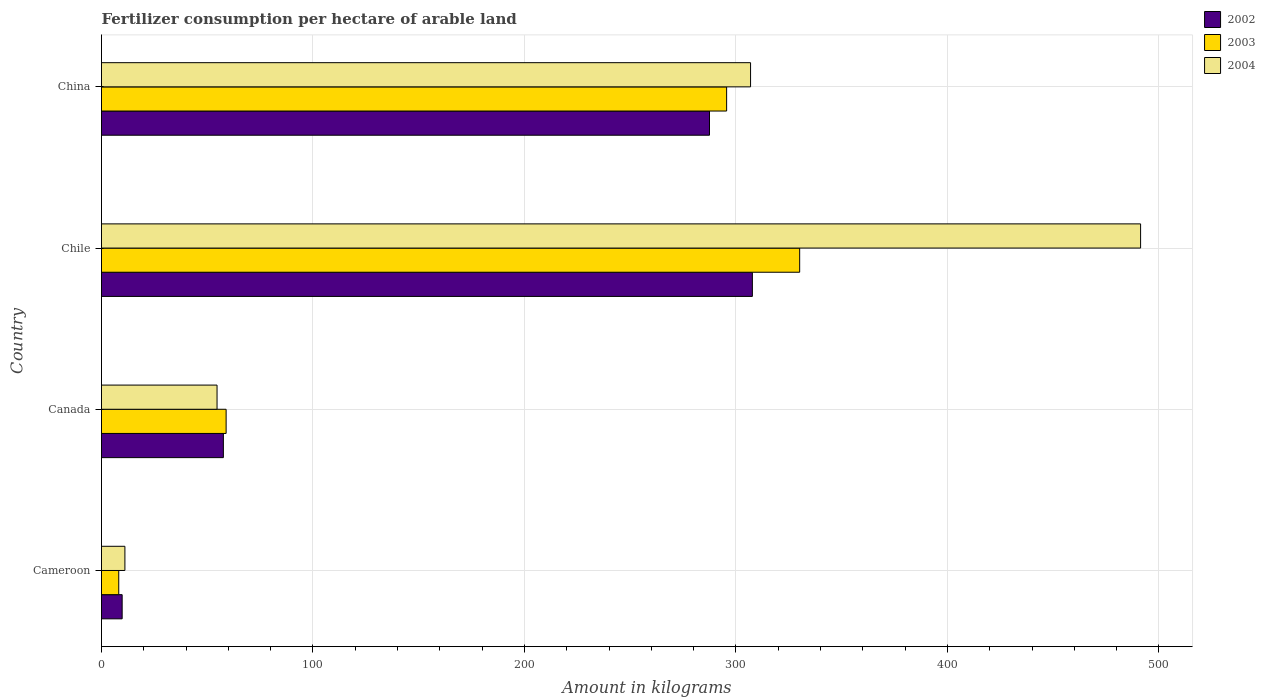How many different coloured bars are there?
Your answer should be compact. 3. What is the label of the 1st group of bars from the top?
Your answer should be very brief. China. What is the amount of fertilizer consumption in 2004 in China?
Offer a terse response. 306.92. Across all countries, what is the maximum amount of fertilizer consumption in 2002?
Ensure brevity in your answer.  307.77. Across all countries, what is the minimum amount of fertilizer consumption in 2003?
Offer a very short reply. 8.16. In which country was the amount of fertilizer consumption in 2004 minimum?
Your answer should be compact. Cameroon. What is the total amount of fertilizer consumption in 2004 in the graph?
Give a very brief answer. 863.97. What is the difference between the amount of fertilizer consumption in 2003 in Canada and that in China?
Offer a very short reply. -236.67. What is the difference between the amount of fertilizer consumption in 2002 in China and the amount of fertilizer consumption in 2003 in Chile?
Make the answer very short. -42.64. What is the average amount of fertilizer consumption in 2002 per country?
Provide a short and direct response. 165.67. What is the difference between the amount of fertilizer consumption in 2004 and amount of fertilizer consumption in 2002 in Chile?
Offer a very short reply. 183.58. In how many countries, is the amount of fertilizer consumption in 2004 greater than 220 kg?
Your answer should be compact. 2. What is the ratio of the amount of fertilizer consumption in 2003 in Cameroon to that in Canada?
Make the answer very short. 0.14. What is the difference between the highest and the second highest amount of fertilizer consumption in 2003?
Give a very brief answer. 34.55. What is the difference between the highest and the lowest amount of fertilizer consumption in 2002?
Offer a terse response. 298. In how many countries, is the amount of fertilizer consumption in 2003 greater than the average amount of fertilizer consumption in 2003 taken over all countries?
Make the answer very short. 2. Is the sum of the amount of fertilizer consumption in 2003 in Cameroon and China greater than the maximum amount of fertilizer consumption in 2004 across all countries?
Give a very brief answer. No. What does the 3rd bar from the top in Chile represents?
Offer a terse response. 2002. What does the 3rd bar from the bottom in Canada represents?
Offer a very short reply. 2004. How many bars are there?
Provide a succinct answer. 12. Are all the bars in the graph horizontal?
Offer a terse response. Yes. How many countries are there in the graph?
Ensure brevity in your answer.  4. Are the values on the major ticks of X-axis written in scientific E-notation?
Make the answer very short. No. Does the graph contain any zero values?
Ensure brevity in your answer.  No. Does the graph contain grids?
Offer a very short reply. Yes. How many legend labels are there?
Keep it short and to the point. 3. How are the legend labels stacked?
Offer a very short reply. Vertical. What is the title of the graph?
Your response must be concise. Fertilizer consumption per hectare of arable land. Does "1961" appear as one of the legend labels in the graph?
Keep it short and to the point. No. What is the label or title of the X-axis?
Keep it short and to the point. Amount in kilograms. What is the Amount in kilograms in 2002 in Cameroon?
Keep it short and to the point. 9.77. What is the Amount in kilograms in 2003 in Cameroon?
Give a very brief answer. 8.16. What is the Amount in kilograms in 2004 in Cameroon?
Ensure brevity in your answer.  11.06. What is the Amount in kilograms of 2002 in Canada?
Your answer should be compact. 57.63. What is the Amount in kilograms of 2003 in Canada?
Make the answer very short. 58.93. What is the Amount in kilograms of 2004 in Canada?
Ensure brevity in your answer.  54.63. What is the Amount in kilograms of 2002 in Chile?
Ensure brevity in your answer.  307.77. What is the Amount in kilograms in 2003 in Chile?
Your answer should be very brief. 330.14. What is the Amount in kilograms of 2004 in Chile?
Make the answer very short. 491.35. What is the Amount in kilograms of 2002 in China?
Your answer should be compact. 287.5. What is the Amount in kilograms in 2003 in China?
Keep it short and to the point. 295.6. What is the Amount in kilograms of 2004 in China?
Make the answer very short. 306.92. Across all countries, what is the maximum Amount in kilograms in 2002?
Make the answer very short. 307.77. Across all countries, what is the maximum Amount in kilograms of 2003?
Provide a succinct answer. 330.14. Across all countries, what is the maximum Amount in kilograms of 2004?
Offer a terse response. 491.35. Across all countries, what is the minimum Amount in kilograms of 2002?
Your answer should be very brief. 9.77. Across all countries, what is the minimum Amount in kilograms in 2003?
Your answer should be compact. 8.16. Across all countries, what is the minimum Amount in kilograms in 2004?
Offer a terse response. 11.06. What is the total Amount in kilograms in 2002 in the graph?
Offer a terse response. 662.67. What is the total Amount in kilograms in 2003 in the graph?
Provide a short and direct response. 692.82. What is the total Amount in kilograms in 2004 in the graph?
Your answer should be very brief. 863.97. What is the difference between the Amount in kilograms of 2002 in Cameroon and that in Canada?
Your answer should be very brief. -47.86. What is the difference between the Amount in kilograms in 2003 in Cameroon and that in Canada?
Offer a terse response. -50.77. What is the difference between the Amount in kilograms in 2004 in Cameroon and that in Canada?
Provide a short and direct response. -43.57. What is the difference between the Amount in kilograms of 2002 in Cameroon and that in Chile?
Keep it short and to the point. -298. What is the difference between the Amount in kilograms in 2003 in Cameroon and that in Chile?
Your response must be concise. -321.99. What is the difference between the Amount in kilograms of 2004 in Cameroon and that in Chile?
Your response must be concise. -480.29. What is the difference between the Amount in kilograms of 2002 in Cameroon and that in China?
Offer a terse response. -277.73. What is the difference between the Amount in kilograms of 2003 in Cameroon and that in China?
Keep it short and to the point. -287.44. What is the difference between the Amount in kilograms in 2004 in Cameroon and that in China?
Provide a succinct answer. -295.85. What is the difference between the Amount in kilograms in 2002 in Canada and that in Chile?
Provide a succinct answer. -250.14. What is the difference between the Amount in kilograms in 2003 in Canada and that in Chile?
Your response must be concise. -271.22. What is the difference between the Amount in kilograms of 2004 in Canada and that in Chile?
Make the answer very short. -436.72. What is the difference between the Amount in kilograms of 2002 in Canada and that in China?
Ensure brevity in your answer.  -229.87. What is the difference between the Amount in kilograms in 2003 in Canada and that in China?
Give a very brief answer. -236.67. What is the difference between the Amount in kilograms in 2004 in Canada and that in China?
Your answer should be compact. -252.28. What is the difference between the Amount in kilograms of 2002 in Chile and that in China?
Ensure brevity in your answer.  20.27. What is the difference between the Amount in kilograms in 2003 in Chile and that in China?
Offer a very short reply. 34.55. What is the difference between the Amount in kilograms of 2004 in Chile and that in China?
Your answer should be very brief. 184.44. What is the difference between the Amount in kilograms of 2002 in Cameroon and the Amount in kilograms of 2003 in Canada?
Make the answer very short. -49.16. What is the difference between the Amount in kilograms in 2002 in Cameroon and the Amount in kilograms in 2004 in Canada?
Your answer should be compact. -44.86. What is the difference between the Amount in kilograms in 2003 in Cameroon and the Amount in kilograms in 2004 in Canada?
Your response must be concise. -46.48. What is the difference between the Amount in kilograms of 2002 in Cameroon and the Amount in kilograms of 2003 in Chile?
Your answer should be very brief. -320.37. What is the difference between the Amount in kilograms of 2002 in Cameroon and the Amount in kilograms of 2004 in Chile?
Keep it short and to the point. -481.58. What is the difference between the Amount in kilograms in 2003 in Cameroon and the Amount in kilograms in 2004 in Chile?
Your response must be concise. -483.2. What is the difference between the Amount in kilograms of 2002 in Cameroon and the Amount in kilograms of 2003 in China?
Offer a very short reply. -285.83. What is the difference between the Amount in kilograms in 2002 in Cameroon and the Amount in kilograms in 2004 in China?
Ensure brevity in your answer.  -297.15. What is the difference between the Amount in kilograms of 2003 in Cameroon and the Amount in kilograms of 2004 in China?
Offer a very short reply. -298.76. What is the difference between the Amount in kilograms of 2002 in Canada and the Amount in kilograms of 2003 in Chile?
Offer a very short reply. -272.51. What is the difference between the Amount in kilograms of 2002 in Canada and the Amount in kilograms of 2004 in Chile?
Your answer should be very brief. -433.72. What is the difference between the Amount in kilograms of 2003 in Canada and the Amount in kilograms of 2004 in Chile?
Keep it short and to the point. -432.43. What is the difference between the Amount in kilograms in 2002 in Canada and the Amount in kilograms in 2003 in China?
Ensure brevity in your answer.  -237.97. What is the difference between the Amount in kilograms in 2002 in Canada and the Amount in kilograms in 2004 in China?
Offer a terse response. -249.29. What is the difference between the Amount in kilograms of 2003 in Canada and the Amount in kilograms of 2004 in China?
Ensure brevity in your answer.  -247.99. What is the difference between the Amount in kilograms in 2002 in Chile and the Amount in kilograms in 2003 in China?
Your answer should be very brief. 12.18. What is the difference between the Amount in kilograms in 2002 in Chile and the Amount in kilograms in 2004 in China?
Ensure brevity in your answer.  0.86. What is the difference between the Amount in kilograms of 2003 in Chile and the Amount in kilograms of 2004 in China?
Your response must be concise. 23.23. What is the average Amount in kilograms of 2002 per country?
Offer a terse response. 165.67. What is the average Amount in kilograms of 2003 per country?
Your response must be concise. 173.21. What is the average Amount in kilograms of 2004 per country?
Your answer should be very brief. 215.99. What is the difference between the Amount in kilograms of 2002 and Amount in kilograms of 2003 in Cameroon?
Your response must be concise. 1.61. What is the difference between the Amount in kilograms in 2002 and Amount in kilograms in 2004 in Cameroon?
Your response must be concise. -1.29. What is the difference between the Amount in kilograms in 2003 and Amount in kilograms in 2004 in Cameroon?
Offer a very short reply. -2.91. What is the difference between the Amount in kilograms of 2002 and Amount in kilograms of 2003 in Canada?
Keep it short and to the point. -1.3. What is the difference between the Amount in kilograms of 2002 and Amount in kilograms of 2004 in Canada?
Offer a very short reply. 3. What is the difference between the Amount in kilograms of 2003 and Amount in kilograms of 2004 in Canada?
Your response must be concise. 4.29. What is the difference between the Amount in kilograms of 2002 and Amount in kilograms of 2003 in Chile?
Your response must be concise. -22.37. What is the difference between the Amount in kilograms of 2002 and Amount in kilograms of 2004 in Chile?
Offer a terse response. -183.58. What is the difference between the Amount in kilograms in 2003 and Amount in kilograms in 2004 in Chile?
Offer a very short reply. -161.21. What is the difference between the Amount in kilograms in 2002 and Amount in kilograms in 2003 in China?
Keep it short and to the point. -8.09. What is the difference between the Amount in kilograms in 2002 and Amount in kilograms in 2004 in China?
Your answer should be compact. -19.42. What is the difference between the Amount in kilograms in 2003 and Amount in kilograms in 2004 in China?
Your response must be concise. -11.32. What is the ratio of the Amount in kilograms of 2002 in Cameroon to that in Canada?
Keep it short and to the point. 0.17. What is the ratio of the Amount in kilograms in 2003 in Cameroon to that in Canada?
Offer a very short reply. 0.14. What is the ratio of the Amount in kilograms in 2004 in Cameroon to that in Canada?
Your answer should be very brief. 0.2. What is the ratio of the Amount in kilograms in 2002 in Cameroon to that in Chile?
Offer a terse response. 0.03. What is the ratio of the Amount in kilograms in 2003 in Cameroon to that in Chile?
Offer a very short reply. 0.02. What is the ratio of the Amount in kilograms of 2004 in Cameroon to that in Chile?
Your response must be concise. 0.02. What is the ratio of the Amount in kilograms in 2002 in Cameroon to that in China?
Ensure brevity in your answer.  0.03. What is the ratio of the Amount in kilograms of 2003 in Cameroon to that in China?
Provide a succinct answer. 0.03. What is the ratio of the Amount in kilograms in 2004 in Cameroon to that in China?
Give a very brief answer. 0.04. What is the ratio of the Amount in kilograms in 2002 in Canada to that in Chile?
Your answer should be compact. 0.19. What is the ratio of the Amount in kilograms in 2003 in Canada to that in Chile?
Keep it short and to the point. 0.18. What is the ratio of the Amount in kilograms in 2004 in Canada to that in Chile?
Your answer should be very brief. 0.11. What is the ratio of the Amount in kilograms in 2002 in Canada to that in China?
Your answer should be very brief. 0.2. What is the ratio of the Amount in kilograms in 2003 in Canada to that in China?
Your response must be concise. 0.2. What is the ratio of the Amount in kilograms in 2004 in Canada to that in China?
Provide a short and direct response. 0.18. What is the ratio of the Amount in kilograms of 2002 in Chile to that in China?
Your response must be concise. 1.07. What is the ratio of the Amount in kilograms of 2003 in Chile to that in China?
Give a very brief answer. 1.12. What is the ratio of the Amount in kilograms in 2004 in Chile to that in China?
Provide a succinct answer. 1.6. What is the difference between the highest and the second highest Amount in kilograms of 2002?
Your answer should be very brief. 20.27. What is the difference between the highest and the second highest Amount in kilograms in 2003?
Keep it short and to the point. 34.55. What is the difference between the highest and the second highest Amount in kilograms in 2004?
Your answer should be compact. 184.44. What is the difference between the highest and the lowest Amount in kilograms of 2002?
Make the answer very short. 298. What is the difference between the highest and the lowest Amount in kilograms of 2003?
Ensure brevity in your answer.  321.99. What is the difference between the highest and the lowest Amount in kilograms in 2004?
Provide a succinct answer. 480.29. 